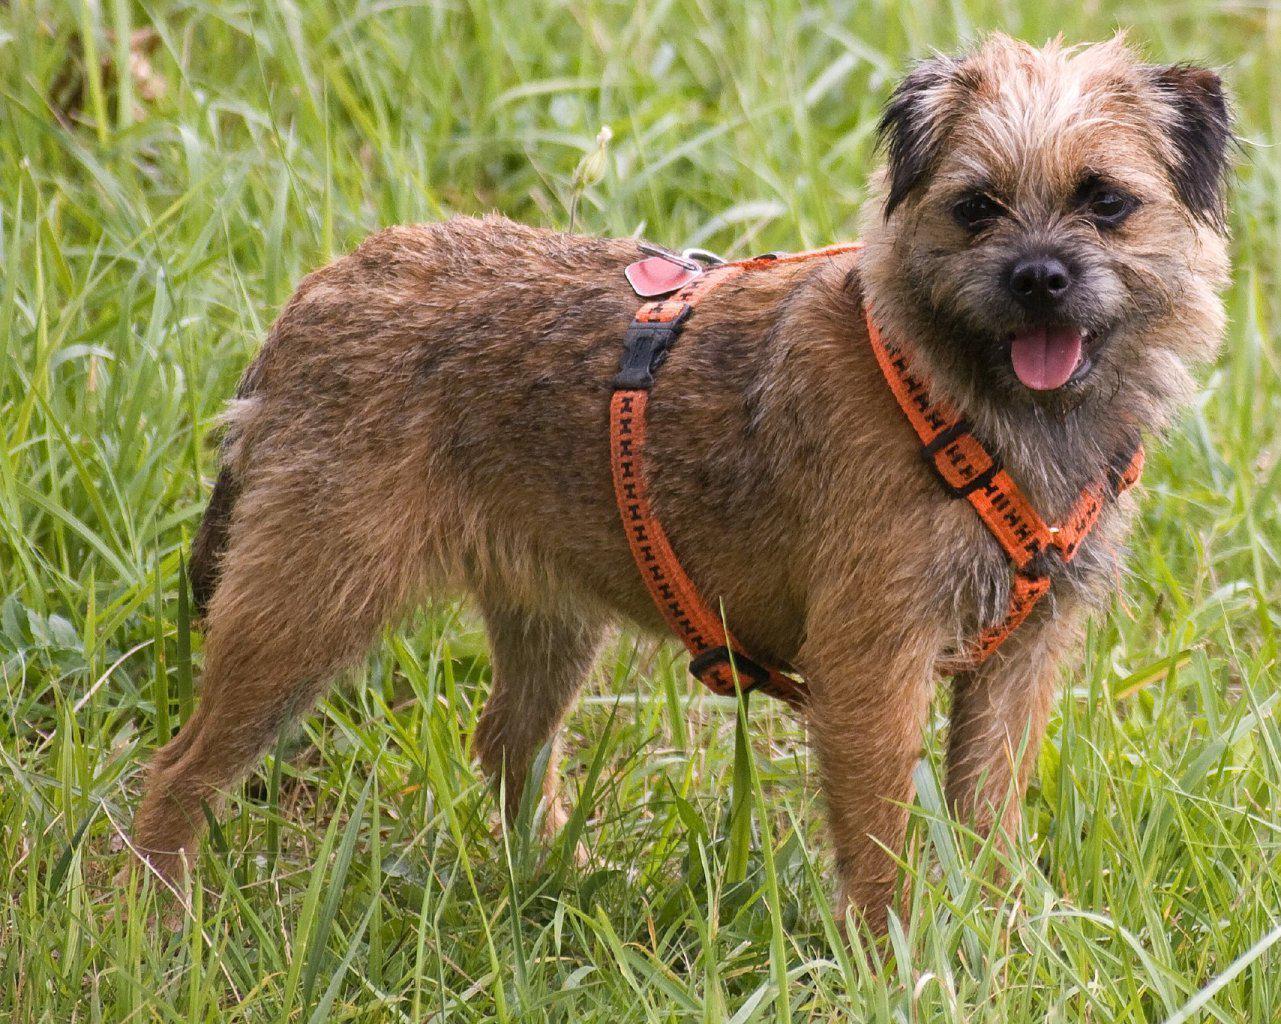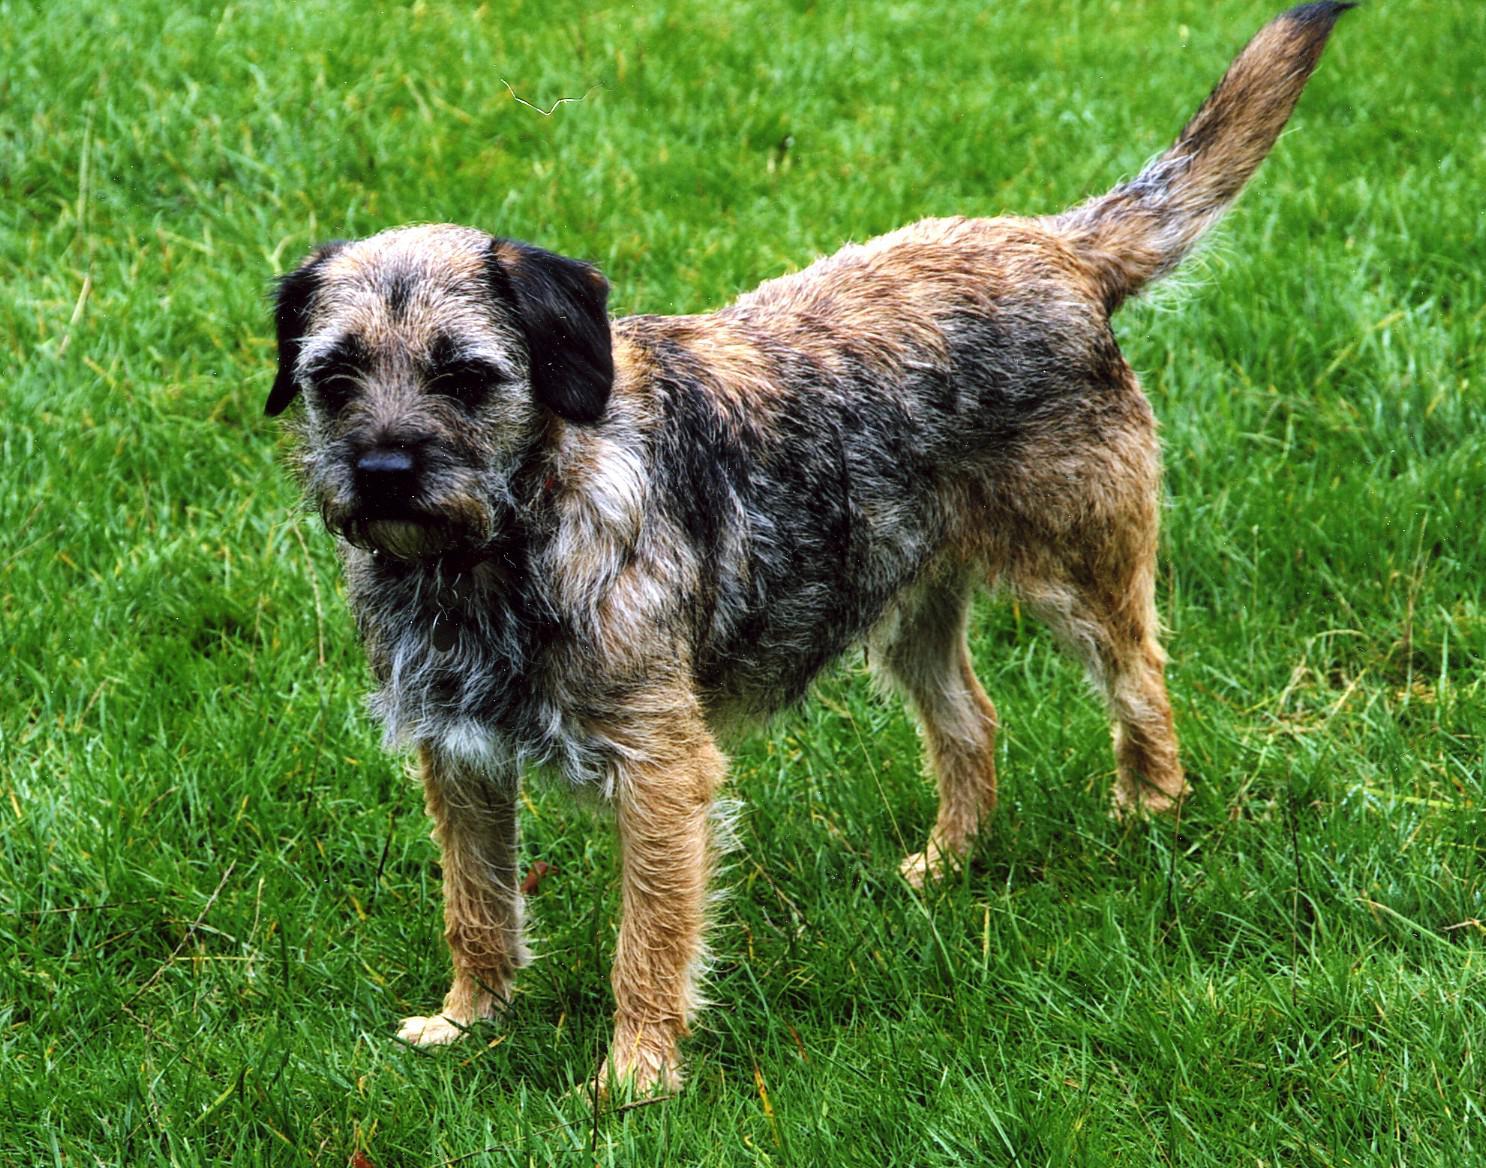The first image is the image on the left, the second image is the image on the right. For the images displayed, is the sentence "One dog is wearing a collar or leash, and the other dog is not." factually correct? Answer yes or no. Yes. The first image is the image on the left, the second image is the image on the right. Examine the images to the left and right. Is the description "1 of the dogs has a tail that is in a resting position." accurate? Answer yes or no. Yes. 